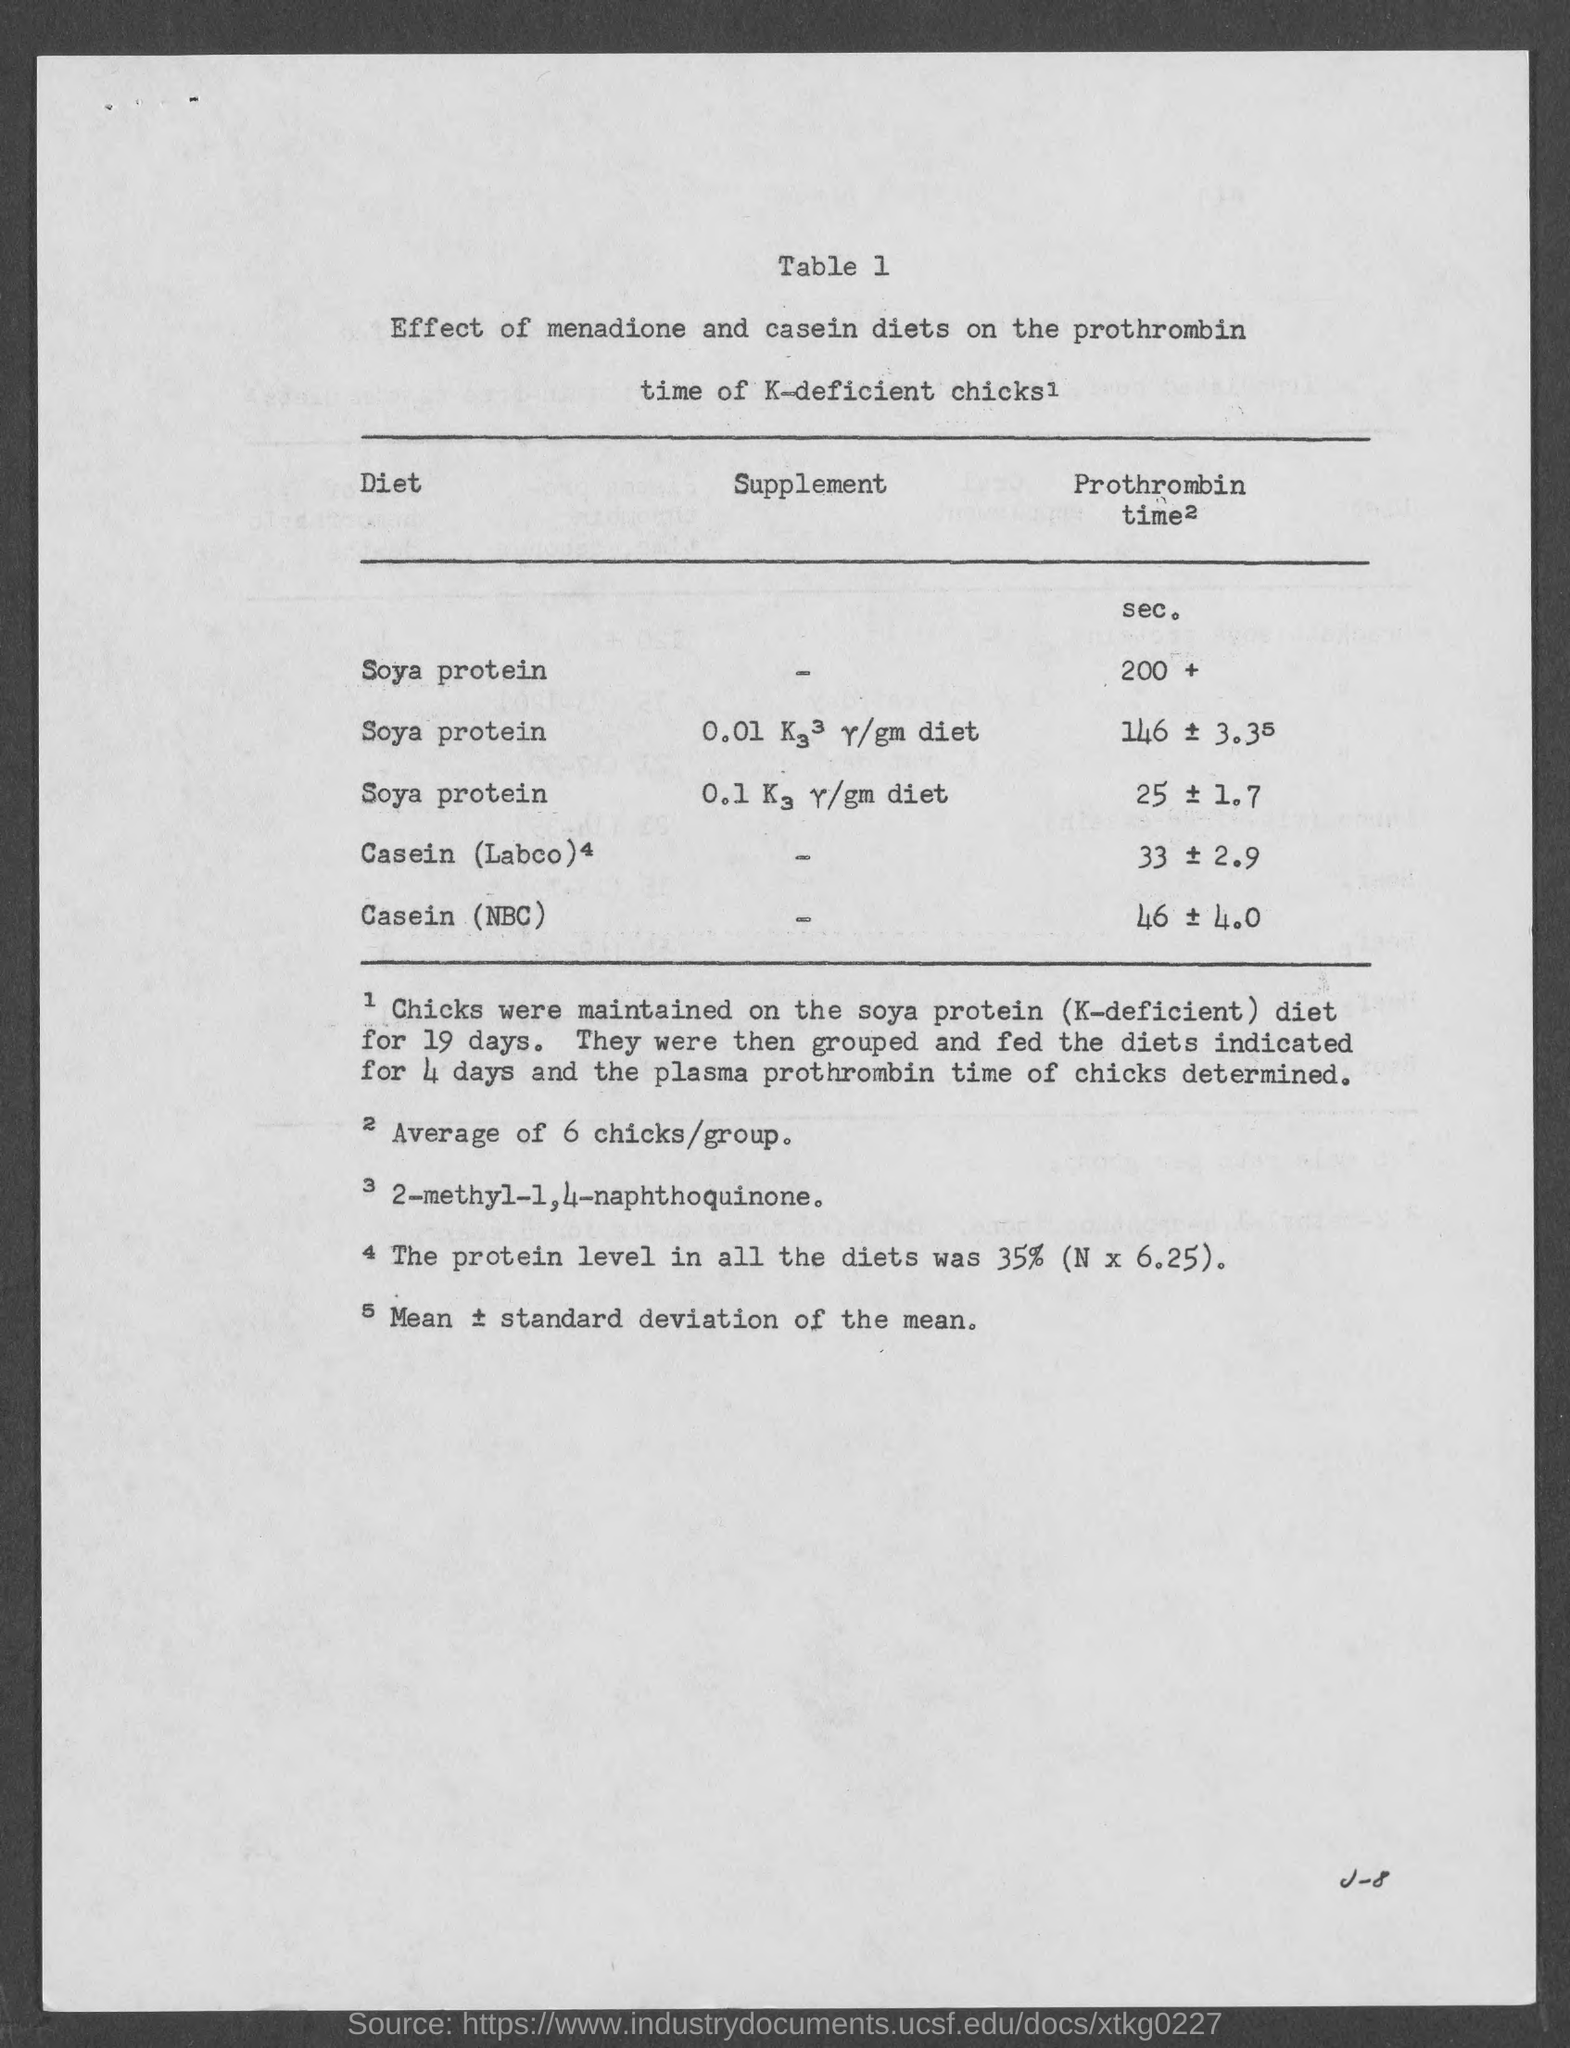What is the table number?
Offer a terse response. Table 1. What is the title of the first column of the table?
Your answer should be very brief. Diet. What is the title of the second column of the table?
Your answer should be very brief. Supplement. 